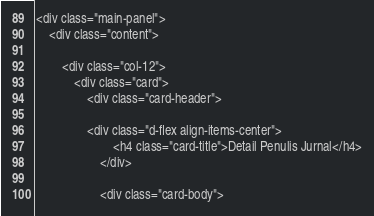<code> <loc_0><loc_0><loc_500><loc_500><_PHP_><div class="main-panel">
    <div class="content">

        <div class="col-12">
            <div class="card">
                <div class="card-header">

                <div class="d-flex align-items-center">
                        <h4 class="card-title">Detail Penulis Jurnal</h4>
                    </div>

                    <div class="card-body"></code> 